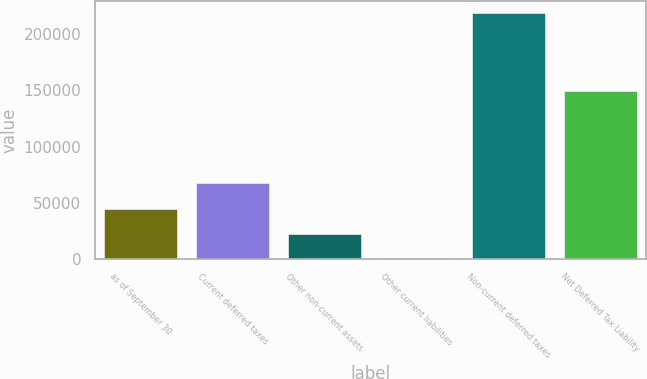Convert chart to OTSL. <chart><loc_0><loc_0><loc_500><loc_500><bar_chart><fcel>as of September 30<fcel>Current deferred taxes<fcel>Other non-current assets<fcel>Other current liabilities<fcel>Non-current deferred taxes<fcel>Net Deferred Tax Liability<nl><fcel>44136.2<fcel>67773<fcel>22297.6<fcel>459<fcel>218845<fcel>149888<nl></chart> 